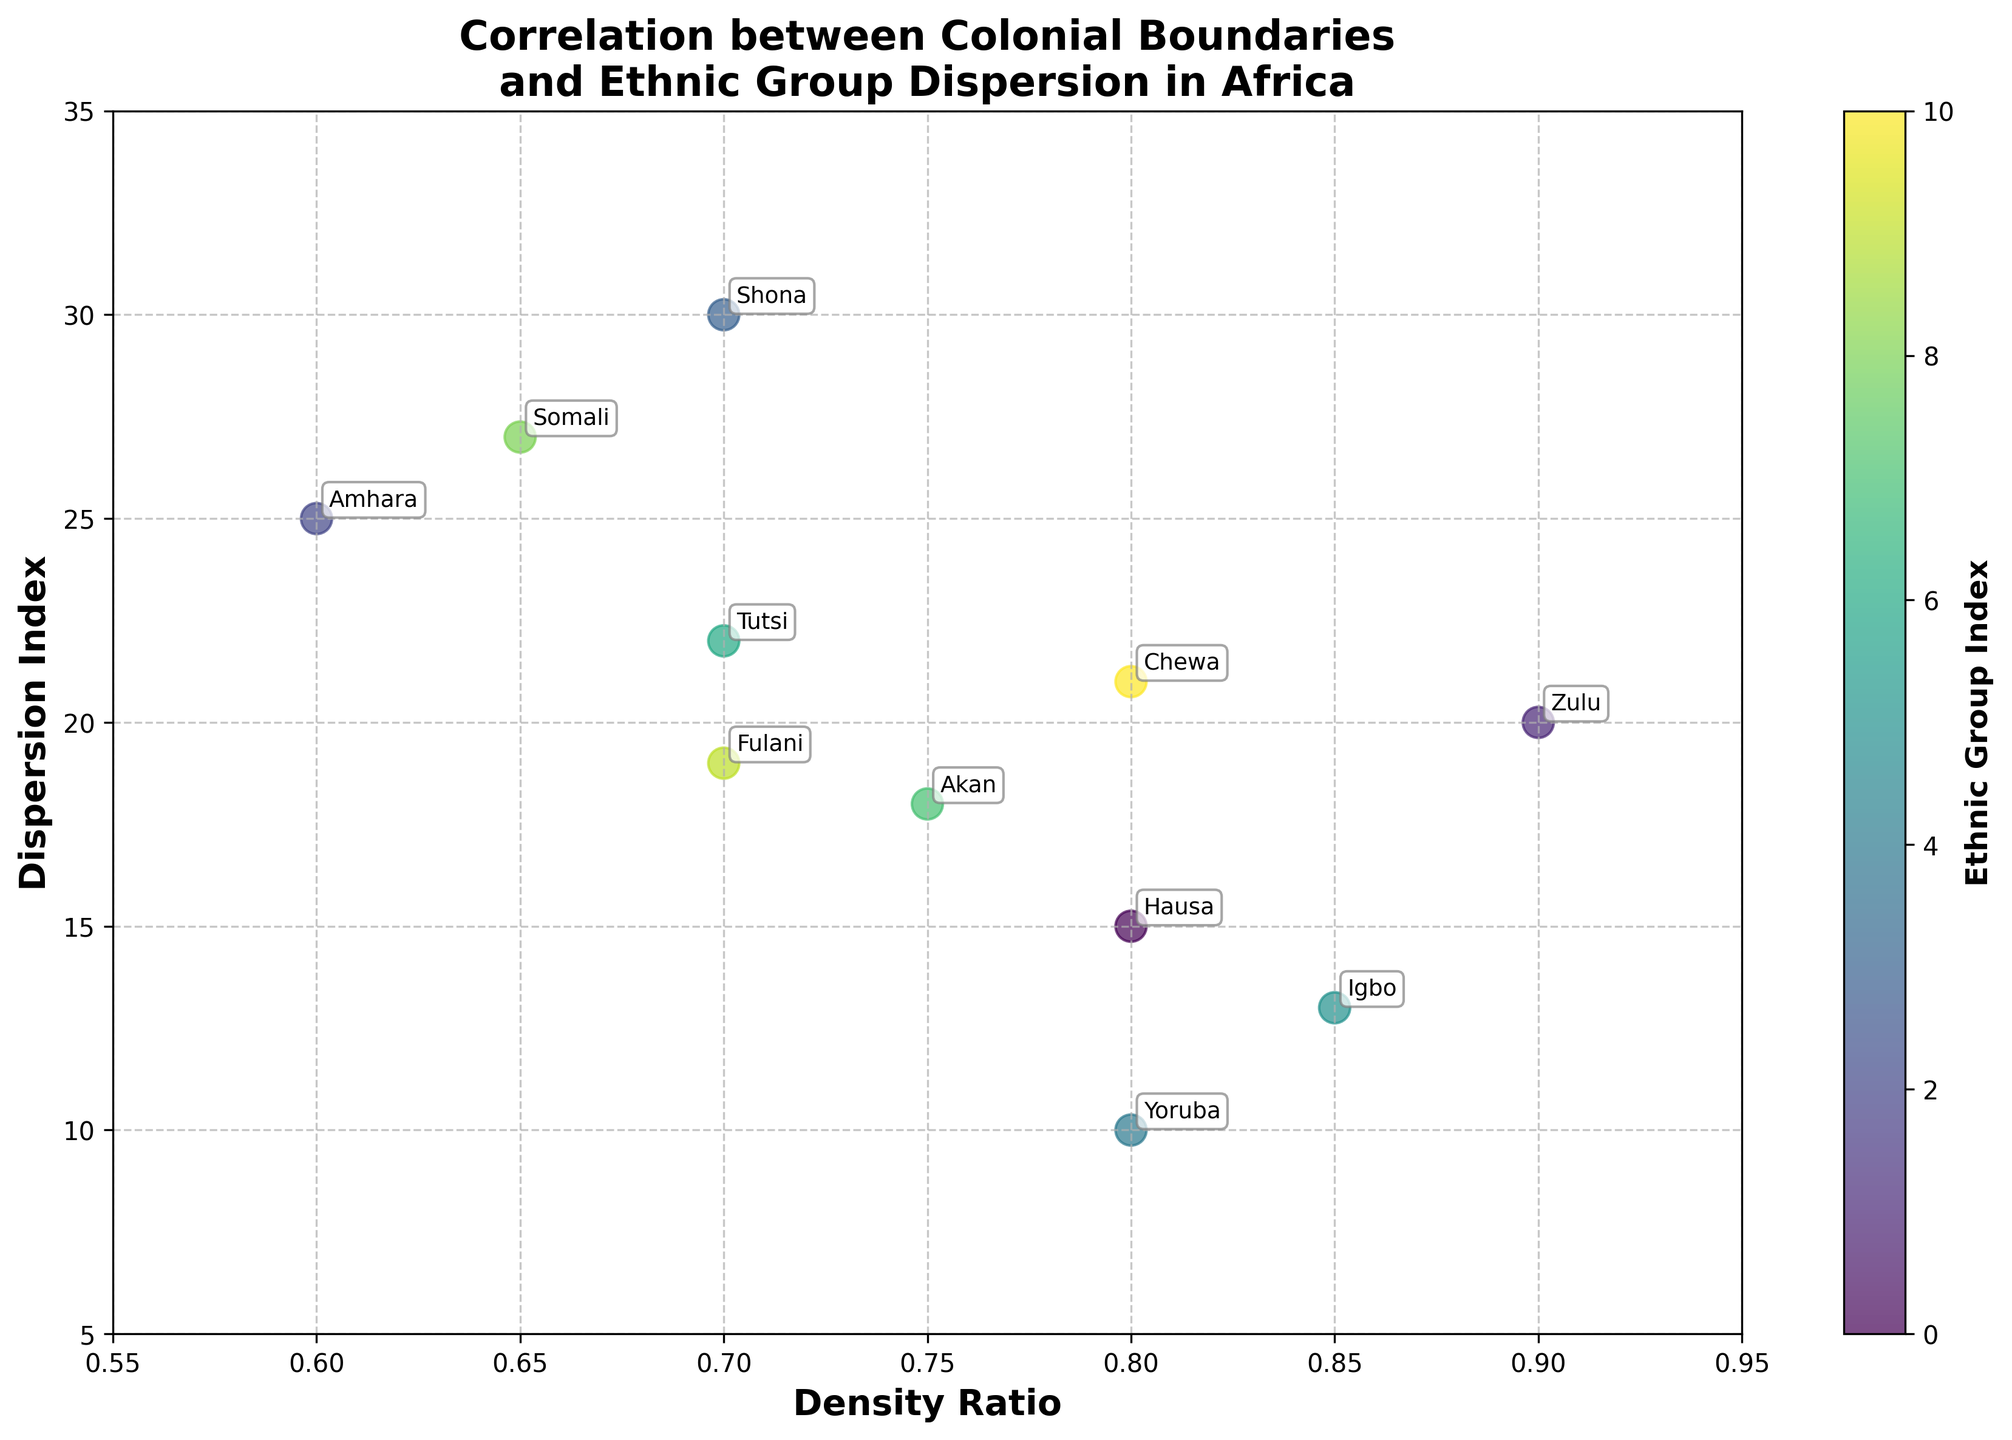What's the title of the scatter plot? The title is located at the top center of the plot. It reads "Correlation between Colonial Boundaries and Ethnic Group Dispersion in Africa".
Answer: Correlation between Colonial Boundaries and Ethnic Group Dispersion in Africa What does the x-axis represent? The x-axis label is found at the bottom of the plot and reads "Density Ratio".
Answer: Density Ratio What does the y-axis measure? The y-axis label is on the left side of the plot and reads "Dispersion Index".
Answer: Dispersion Index Which ethnic group has the highest Dispersion Index? By looking at the y-axis values, the Amhara ethnic group has the highest y-value of 25.
Answer: Amhara How many data points are visible in the scatter plot? By counting the unique points in the scatter plot, there are 11 data points corresponding to different ethnic groups.
Answer: 11 Which ethnic group has the lowest Density Ratio? According to the position closest to the x-axis minimum value, the Amhara ethnic group has the lowest Density Ratio of 0.6.
Answer: Amhara What is the Density Ratio and Dispersion Index for the Hausa ethnic group? By finding the "Hausa" label on the plot, it shows a Density Ratio of 0.8 and a Dispersion Index of 15.
Answer: 0.8 Density Ratio, 15 Dispersion Index Which ethnic group has a Density Ratio of 0.9? By checking the point at 0.9 on the x-axis, it corresponds to the Zulu ethnic group.
Answer: Zulu Which ethnic group has the closest Density Ratio to 0.75? Through comparison, the Akan ethnic group has a Density Ratio of 0.75, which matches exactly.
Answer: Akan What is the average Dispersion Index of the Igbo and Yoruba ethnic groups? The Dispersion Index of Igbo is 13, and Yoruba is 10. (13 + 10) / 2 = 11.5.
Answer: 11.5 